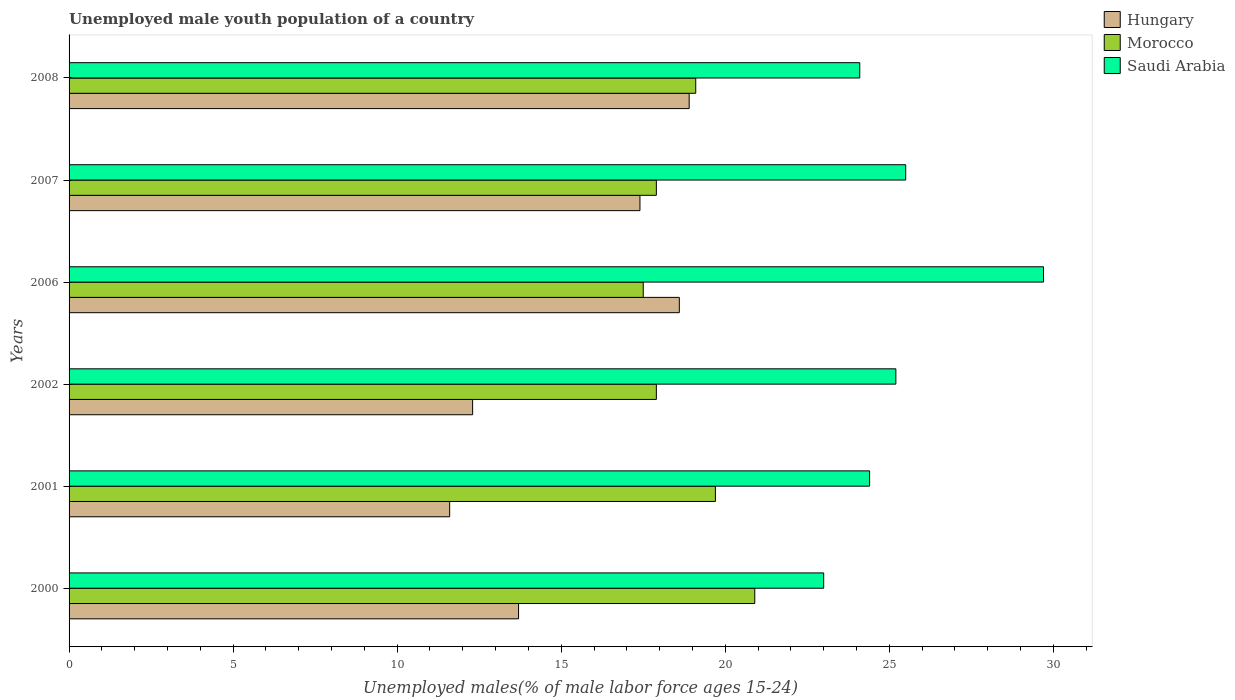How many different coloured bars are there?
Ensure brevity in your answer.  3. How many groups of bars are there?
Make the answer very short. 6. How many bars are there on the 5th tick from the top?
Ensure brevity in your answer.  3. How many bars are there on the 5th tick from the bottom?
Keep it short and to the point. 3. What is the label of the 6th group of bars from the top?
Offer a very short reply. 2000. In how many cases, is the number of bars for a given year not equal to the number of legend labels?
Ensure brevity in your answer.  0. What is the percentage of unemployed male youth population in Hungary in 2000?
Your answer should be compact. 13.7. Across all years, what is the maximum percentage of unemployed male youth population in Morocco?
Offer a very short reply. 20.9. In which year was the percentage of unemployed male youth population in Hungary minimum?
Keep it short and to the point. 2001. What is the total percentage of unemployed male youth population in Hungary in the graph?
Make the answer very short. 92.5. What is the difference between the percentage of unemployed male youth population in Saudi Arabia in 2006 and that in 2007?
Ensure brevity in your answer.  4.2. What is the difference between the percentage of unemployed male youth population in Saudi Arabia in 2006 and the percentage of unemployed male youth population in Morocco in 2007?
Give a very brief answer. 11.8. What is the average percentage of unemployed male youth population in Morocco per year?
Provide a succinct answer. 18.83. In the year 2001, what is the difference between the percentage of unemployed male youth population in Hungary and percentage of unemployed male youth population in Saudi Arabia?
Offer a terse response. -12.8. What is the ratio of the percentage of unemployed male youth population in Saudi Arabia in 2000 to that in 2007?
Give a very brief answer. 0.9. What is the difference between the highest and the second highest percentage of unemployed male youth population in Hungary?
Provide a succinct answer. 0.3. What is the difference between the highest and the lowest percentage of unemployed male youth population in Saudi Arabia?
Your answer should be very brief. 6.7. In how many years, is the percentage of unemployed male youth population in Hungary greater than the average percentage of unemployed male youth population in Hungary taken over all years?
Your answer should be very brief. 3. Is the sum of the percentage of unemployed male youth population in Morocco in 2006 and 2007 greater than the maximum percentage of unemployed male youth population in Saudi Arabia across all years?
Provide a short and direct response. Yes. What does the 1st bar from the top in 2000 represents?
Offer a very short reply. Saudi Arabia. What does the 2nd bar from the bottom in 2002 represents?
Provide a succinct answer. Morocco. Is it the case that in every year, the sum of the percentage of unemployed male youth population in Saudi Arabia and percentage of unemployed male youth population in Hungary is greater than the percentage of unemployed male youth population in Morocco?
Provide a succinct answer. Yes. Are the values on the major ticks of X-axis written in scientific E-notation?
Provide a short and direct response. No. Does the graph contain any zero values?
Offer a very short reply. No. Where does the legend appear in the graph?
Provide a short and direct response. Top right. How are the legend labels stacked?
Keep it short and to the point. Vertical. What is the title of the graph?
Offer a very short reply. Unemployed male youth population of a country. What is the label or title of the X-axis?
Your answer should be very brief. Unemployed males(% of male labor force ages 15-24). What is the Unemployed males(% of male labor force ages 15-24) in Hungary in 2000?
Provide a short and direct response. 13.7. What is the Unemployed males(% of male labor force ages 15-24) of Morocco in 2000?
Offer a very short reply. 20.9. What is the Unemployed males(% of male labor force ages 15-24) of Hungary in 2001?
Provide a succinct answer. 11.6. What is the Unemployed males(% of male labor force ages 15-24) of Morocco in 2001?
Provide a short and direct response. 19.7. What is the Unemployed males(% of male labor force ages 15-24) in Saudi Arabia in 2001?
Make the answer very short. 24.4. What is the Unemployed males(% of male labor force ages 15-24) in Hungary in 2002?
Ensure brevity in your answer.  12.3. What is the Unemployed males(% of male labor force ages 15-24) of Morocco in 2002?
Your answer should be compact. 17.9. What is the Unemployed males(% of male labor force ages 15-24) of Saudi Arabia in 2002?
Your answer should be compact. 25.2. What is the Unemployed males(% of male labor force ages 15-24) of Hungary in 2006?
Your answer should be very brief. 18.6. What is the Unemployed males(% of male labor force ages 15-24) of Morocco in 2006?
Give a very brief answer. 17.5. What is the Unemployed males(% of male labor force ages 15-24) in Saudi Arabia in 2006?
Provide a succinct answer. 29.7. What is the Unemployed males(% of male labor force ages 15-24) of Hungary in 2007?
Offer a terse response. 17.4. What is the Unemployed males(% of male labor force ages 15-24) of Morocco in 2007?
Give a very brief answer. 17.9. What is the Unemployed males(% of male labor force ages 15-24) in Saudi Arabia in 2007?
Your answer should be very brief. 25.5. What is the Unemployed males(% of male labor force ages 15-24) of Hungary in 2008?
Your response must be concise. 18.9. What is the Unemployed males(% of male labor force ages 15-24) of Morocco in 2008?
Make the answer very short. 19.1. What is the Unemployed males(% of male labor force ages 15-24) of Saudi Arabia in 2008?
Keep it short and to the point. 24.1. Across all years, what is the maximum Unemployed males(% of male labor force ages 15-24) of Hungary?
Your response must be concise. 18.9. Across all years, what is the maximum Unemployed males(% of male labor force ages 15-24) in Morocco?
Make the answer very short. 20.9. Across all years, what is the maximum Unemployed males(% of male labor force ages 15-24) of Saudi Arabia?
Your answer should be compact. 29.7. Across all years, what is the minimum Unemployed males(% of male labor force ages 15-24) in Hungary?
Offer a terse response. 11.6. Across all years, what is the minimum Unemployed males(% of male labor force ages 15-24) in Morocco?
Offer a very short reply. 17.5. What is the total Unemployed males(% of male labor force ages 15-24) of Hungary in the graph?
Give a very brief answer. 92.5. What is the total Unemployed males(% of male labor force ages 15-24) in Morocco in the graph?
Offer a very short reply. 113. What is the total Unemployed males(% of male labor force ages 15-24) in Saudi Arabia in the graph?
Make the answer very short. 151.9. What is the difference between the Unemployed males(% of male labor force ages 15-24) in Morocco in 2000 and that in 2001?
Ensure brevity in your answer.  1.2. What is the difference between the Unemployed males(% of male labor force ages 15-24) of Saudi Arabia in 2000 and that in 2001?
Make the answer very short. -1.4. What is the difference between the Unemployed males(% of male labor force ages 15-24) of Saudi Arabia in 2000 and that in 2002?
Your answer should be compact. -2.2. What is the difference between the Unemployed males(% of male labor force ages 15-24) in Hungary in 2000 and that in 2006?
Offer a very short reply. -4.9. What is the difference between the Unemployed males(% of male labor force ages 15-24) of Morocco in 2000 and that in 2006?
Give a very brief answer. 3.4. What is the difference between the Unemployed males(% of male labor force ages 15-24) in Hungary in 2000 and that in 2007?
Your answer should be very brief. -3.7. What is the difference between the Unemployed males(% of male labor force ages 15-24) of Saudi Arabia in 2000 and that in 2007?
Provide a succinct answer. -2.5. What is the difference between the Unemployed males(% of male labor force ages 15-24) of Hungary in 2000 and that in 2008?
Offer a terse response. -5.2. What is the difference between the Unemployed males(% of male labor force ages 15-24) of Morocco in 2000 and that in 2008?
Make the answer very short. 1.8. What is the difference between the Unemployed males(% of male labor force ages 15-24) of Saudi Arabia in 2000 and that in 2008?
Offer a very short reply. -1.1. What is the difference between the Unemployed males(% of male labor force ages 15-24) in Hungary in 2001 and that in 2002?
Your answer should be very brief. -0.7. What is the difference between the Unemployed males(% of male labor force ages 15-24) in Morocco in 2001 and that in 2002?
Your answer should be very brief. 1.8. What is the difference between the Unemployed males(% of male labor force ages 15-24) in Hungary in 2001 and that in 2006?
Provide a short and direct response. -7. What is the difference between the Unemployed males(% of male labor force ages 15-24) of Morocco in 2001 and that in 2006?
Give a very brief answer. 2.2. What is the difference between the Unemployed males(% of male labor force ages 15-24) in Morocco in 2001 and that in 2008?
Your response must be concise. 0.6. What is the difference between the Unemployed males(% of male labor force ages 15-24) of Saudi Arabia in 2001 and that in 2008?
Keep it short and to the point. 0.3. What is the difference between the Unemployed males(% of male labor force ages 15-24) in Hungary in 2002 and that in 2007?
Your response must be concise. -5.1. What is the difference between the Unemployed males(% of male labor force ages 15-24) in Saudi Arabia in 2002 and that in 2007?
Offer a very short reply. -0.3. What is the difference between the Unemployed males(% of male labor force ages 15-24) of Hungary in 2006 and that in 2007?
Your answer should be compact. 1.2. What is the difference between the Unemployed males(% of male labor force ages 15-24) in Hungary in 2006 and that in 2008?
Your response must be concise. -0.3. What is the difference between the Unemployed males(% of male labor force ages 15-24) of Morocco in 2006 and that in 2008?
Your answer should be compact. -1.6. What is the difference between the Unemployed males(% of male labor force ages 15-24) in Saudi Arabia in 2006 and that in 2008?
Offer a very short reply. 5.6. What is the difference between the Unemployed males(% of male labor force ages 15-24) in Saudi Arabia in 2007 and that in 2008?
Your answer should be compact. 1.4. What is the difference between the Unemployed males(% of male labor force ages 15-24) of Hungary in 2000 and the Unemployed males(% of male labor force ages 15-24) of Morocco in 2001?
Your response must be concise. -6. What is the difference between the Unemployed males(% of male labor force ages 15-24) of Hungary in 2000 and the Unemployed males(% of male labor force ages 15-24) of Saudi Arabia in 2001?
Provide a short and direct response. -10.7. What is the difference between the Unemployed males(% of male labor force ages 15-24) in Morocco in 2000 and the Unemployed males(% of male labor force ages 15-24) in Saudi Arabia in 2001?
Ensure brevity in your answer.  -3.5. What is the difference between the Unemployed males(% of male labor force ages 15-24) of Hungary in 2000 and the Unemployed males(% of male labor force ages 15-24) of Saudi Arabia in 2002?
Provide a short and direct response. -11.5. What is the difference between the Unemployed males(% of male labor force ages 15-24) in Morocco in 2000 and the Unemployed males(% of male labor force ages 15-24) in Saudi Arabia in 2002?
Offer a very short reply. -4.3. What is the difference between the Unemployed males(% of male labor force ages 15-24) in Hungary in 2000 and the Unemployed males(% of male labor force ages 15-24) in Morocco in 2007?
Your answer should be very brief. -4.2. What is the difference between the Unemployed males(% of male labor force ages 15-24) in Hungary in 2000 and the Unemployed males(% of male labor force ages 15-24) in Saudi Arabia in 2008?
Provide a short and direct response. -10.4. What is the difference between the Unemployed males(% of male labor force ages 15-24) of Hungary in 2001 and the Unemployed males(% of male labor force ages 15-24) of Morocco in 2002?
Offer a very short reply. -6.3. What is the difference between the Unemployed males(% of male labor force ages 15-24) in Morocco in 2001 and the Unemployed males(% of male labor force ages 15-24) in Saudi Arabia in 2002?
Offer a very short reply. -5.5. What is the difference between the Unemployed males(% of male labor force ages 15-24) in Hungary in 2001 and the Unemployed males(% of male labor force ages 15-24) in Saudi Arabia in 2006?
Provide a short and direct response. -18.1. What is the difference between the Unemployed males(% of male labor force ages 15-24) in Hungary in 2001 and the Unemployed males(% of male labor force ages 15-24) in Morocco in 2007?
Ensure brevity in your answer.  -6.3. What is the difference between the Unemployed males(% of male labor force ages 15-24) in Hungary in 2001 and the Unemployed males(% of male labor force ages 15-24) in Saudi Arabia in 2007?
Provide a succinct answer. -13.9. What is the difference between the Unemployed males(% of male labor force ages 15-24) in Morocco in 2001 and the Unemployed males(% of male labor force ages 15-24) in Saudi Arabia in 2007?
Make the answer very short. -5.8. What is the difference between the Unemployed males(% of male labor force ages 15-24) of Hungary in 2001 and the Unemployed males(% of male labor force ages 15-24) of Morocco in 2008?
Ensure brevity in your answer.  -7.5. What is the difference between the Unemployed males(% of male labor force ages 15-24) of Hungary in 2001 and the Unemployed males(% of male labor force ages 15-24) of Saudi Arabia in 2008?
Your answer should be very brief. -12.5. What is the difference between the Unemployed males(% of male labor force ages 15-24) in Hungary in 2002 and the Unemployed males(% of male labor force ages 15-24) in Morocco in 2006?
Your answer should be very brief. -5.2. What is the difference between the Unemployed males(% of male labor force ages 15-24) of Hungary in 2002 and the Unemployed males(% of male labor force ages 15-24) of Saudi Arabia in 2006?
Your response must be concise. -17.4. What is the difference between the Unemployed males(% of male labor force ages 15-24) in Morocco in 2002 and the Unemployed males(% of male labor force ages 15-24) in Saudi Arabia in 2006?
Offer a terse response. -11.8. What is the difference between the Unemployed males(% of male labor force ages 15-24) in Morocco in 2002 and the Unemployed males(% of male labor force ages 15-24) in Saudi Arabia in 2008?
Give a very brief answer. -6.2. What is the difference between the Unemployed males(% of male labor force ages 15-24) in Hungary in 2006 and the Unemployed males(% of male labor force ages 15-24) in Morocco in 2007?
Offer a terse response. 0.7. What is the difference between the Unemployed males(% of male labor force ages 15-24) of Morocco in 2006 and the Unemployed males(% of male labor force ages 15-24) of Saudi Arabia in 2007?
Your answer should be compact. -8. What is the difference between the Unemployed males(% of male labor force ages 15-24) of Morocco in 2007 and the Unemployed males(% of male labor force ages 15-24) of Saudi Arabia in 2008?
Provide a short and direct response. -6.2. What is the average Unemployed males(% of male labor force ages 15-24) of Hungary per year?
Ensure brevity in your answer.  15.42. What is the average Unemployed males(% of male labor force ages 15-24) in Morocco per year?
Keep it short and to the point. 18.83. What is the average Unemployed males(% of male labor force ages 15-24) of Saudi Arabia per year?
Give a very brief answer. 25.32. In the year 2000, what is the difference between the Unemployed males(% of male labor force ages 15-24) of Hungary and Unemployed males(% of male labor force ages 15-24) of Morocco?
Offer a terse response. -7.2. In the year 2000, what is the difference between the Unemployed males(% of male labor force ages 15-24) of Hungary and Unemployed males(% of male labor force ages 15-24) of Saudi Arabia?
Keep it short and to the point. -9.3. In the year 2001, what is the difference between the Unemployed males(% of male labor force ages 15-24) in Hungary and Unemployed males(% of male labor force ages 15-24) in Morocco?
Provide a succinct answer. -8.1. In the year 2001, what is the difference between the Unemployed males(% of male labor force ages 15-24) of Morocco and Unemployed males(% of male labor force ages 15-24) of Saudi Arabia?
Ensure brevity in your answer.  -4.7. In the year 2002, what is the difference between the Unemployed males(% of male labor force ages 15-24) of Hungary and Unemployed males(% of male labor force ages 15-24) of Morocco?
Offer a very short reply. -5.6. In the year 2008, what is the difference between the Unemployed males(% of male labor force ages 15-24) in Hungary and Unemployed males(% of male labor force ages 15-24) in Morocco?
Your answer should be compact. -0.2. In the year 2008, what is the difference between the Unemployed males(% of male labor force ages 15-24) in Hungary and Unemployed males(% of male labor force ages 15-24) in Saudi Arabia?
Your response must be concise. -5.2. In the year 2008, what is the difference between the Unemployed males(% of male labor force ages 15-24) of Morocco and Unemployed males(% of male labor force ages 15-24) of Saudi Arabia?
Provide a short and direct response. -5. What is the ratio of the Unemployed males(% of male labor force ages 15-24) in Hungary in 2000 to that in 2001?
Your answer should be very brief. 1.18. What is the ratio of the Unemployed males(% of male labor force ages 15-24) in Morocco in 2000 to that in 2001?
Offer a terse response. 1.06. What is the ratio of the Unemployed males(% of male labor force ages 15-24) of Saudi Arabia in 2000 to that in 2001?
Make the answer very short. 0.94. What is the ratio of the Unemployed males(% of male labor force ages 15-24) in Hungary in 2000 to that in 2002?
Make the answer very short. 1.11. What is the ratio of the Unemployed males(% of male labor force ages 15-24) of Morocco in 2000 to that in 2002?
Ensure brevity in your answer.  1.17. What is the ratio of the Unemployed males(% of male labor force ages 15-24) in Saudi Arabia in 2000 to that in 2002?
Make the answer very short. 0.91. What is the ratio of the Unemployed males(% of male labor force ages 15-24) of Hungary in 2000 to that in 2006?
Keep it short and to the point. 0.74. What is the ratio of the Unemployed males(% of male labor force ages 15-24) in Morocco in 2000 to that in 2006?
Provide a short and direct response. 1.19. What is the ratio of the Unemployed males(% of male labor force ages 15-24) of Saudi Arabia in 2000 to that in 2006?
Provide a short and direct response. 0.77. What is the ratio of the Unemployed males(% of male labor force ages 15-24) in Hungary in 2000 to that in 2007?
Offer a terse response. 0.79. What is the ratio of the Unemployed males(% of male labor force ages 15-24) in Morocco in 2000 to that in 2007?
Your response must be concise. 1.17. What is the ratio of the Unemployed males(% of male labor force ages 15-24) of Saudi Arabia in 2000 to that in 2007?
Make the answer very short. 0.9. What is the ratio of the Unemployed males(% of male labor force ages 15-24) in Hungary in 2000 to that in 2008?
Provide a short and direct response. 0.72. What is the ratio of the Unemployed males(% of male labor force ages 15-24) of Morocco in 2000 to that in 2008?
Provide a succinct answer. 1.09. What is the ratio of the Unemployed males(% of male labor force ages 15-24) in Saudi Arabia in 2000 to that in 2008?
Your response must be concise. 0.95. What is the ratio of the Unemployed males(% of male labor force ages 15-24) in Hungary in 2001 to that in 2002?
Provide a short and direct response. 0.94. What is the ratio of the Unemployed males(% of male labor force ages 15-24) of Morocco in 2001 to that in 2002?
Your response must be concise. 1.1. What is the ratio of the Unemployed males(% of male labor force ages 15-24) in Saudi Arabia in 2001 to that in 2002?
Your answer should be compact. 0.97. What is the ratio of the Unemployed males(% of male labor force ages 15-24) of Hungary in 2001 to that in 2006?
Keep it short and to the point. 0.62. What is the ratio of the Unemployed males(% of male labor force ages 15-24) of Morocco in 2001 to that in 2006?
Your response must be concise. 1.13. What is the ratio of the Unemployed males(% of male labor force ages 15-24) in Saudi Arabia in 2001 to that in 2006?
Offer a terse response. 0.82. What is the ratio of the Unemployed males(% of male labor force ages 15-24) in Morocco in 2001 to that in 2007?
Offer a terse response. 1.1. What is the ratio of the Unemployed males(% of male labor force ages 15-24) in Saudi Arabia in 2001 to that in 2007?
Give a very brief answer. 0.96. What is the ratio of the Unemployed males(% of male labor force ages 15-24) in Hungary in 2001 to that in 2008?
Provide a short and direct response. 0.61. What is the ratio of the Unemployed males(% of male labor force ages 15-24) of Morocco in 2001 to that in 2008?
Your answer should be compact. 1.03. What is the ratio of the Unemployed males(% of male labor force ages 15-24) of Saudi Arabia in 2001 to that in 2008?
Provide a succinct answer. 1.01. What is the ratio of the Unemployed males(% of male labor force ages 15-24) of Hungary in 2002 to that in 2006?
Provide a succinct answer. 0.66. What is the ratio of the Unemployed males(% of male labor force ages 15-24) of Morocco in 2002 to that in 2006?
Keep it short and to the point. 1.02. What is the ratio of the Unemployed males(% of male labor force ages 15-24) of Saudi Arabia in 2002 to that in 2006?
Provide a short and direct response. 0.85. What is the ratio of the Unemployed males(% of male labor force ages 15-24) of Hungary in 2002 to that in 2007?
Provide a short and direct response. 0.71. What is the ratio of the Unemployed males(% of male labor force ages 15-24) of Morocco in 2002 to that in 2007?
Your answer should be compact. 1. What is the ratio of the Unemployed males(% of male labor force ages 15-24) in Hungary in 2002 to that in 2008?
Make the answer very short. 0.65. What is the ratio of the Unemployed males(% of male labor force ages 15-24) of Morocco in 2002 to that in 2008?
Keep it short and to the point. 0.94. What is the ratio of the Unemployed males(% of male labor force ages 15-24) in Saudi Arabia in 2002 to that in 2008?
Provide a succinct answer. 1.05. What is the ratio of the Unemployed males(% of male labor force ages 15-24) in Hungary in 2006 to that in 2007?
Provide a succinct answer. 1.07. What is the ratio of the Unemployed males(% of male labor force ages 15-24) of Morocco in 2006 to that in 2007?
Offer a terse response. 0.98. What is the ratio of the Unemployed males(% of male labor force ages 15-24) of Saudi Arabia in 2006 to that in 2007?
Give a very brief answer. 1.16. What is the ratio of the Unemployed males(% of male labor force ages 15-24) of Hungary in 2006 to that in 2008?
Your answer should be compact. 0.98. What is the ratio of the Unemployed males(% of male labor force ages 15-24) of Morocco in 2006 to that in 2008?
Offer a very short reply. 0.92. What is the ratio of the Unemployed males(% of male labor force ages 15-24) in Saudi Arabia in 2006 to that in 2008?
Your answer should be very brief. 1.23. What is the ratio of the Unemployed males(% of male labor force ages 15-24) of Hungary in 2007 to that in 2008?
Your answer should be very brief. 0.92. What is the ratio of the Unemployed males(% of male labor force ages 15-24) of Morocco in 2007 to that in 2008?
Make the answer very short. 0.94. What is the ratio of the Unemployed males(% of male labor force ages 15-24) in Saudi Arabia in 2007 to that in 2008?
Ensure brevity in your answer.  1.06. What is the difference between the highest and the second highest Unemployed males(% of male labor force ages 15-24) of Hungary?
Your response must be concise. 0.3. What is the difference between the highest and the second highest Unemployed males(% of male labor force ages 15-24) in Morocco?
Make the answer very short. 1.2. What is the difference between the highest and the second highest Unemployed males(% of male labor force ages 15-24) in Saudi Arabia?
Your answer should be compact. 4.2. What is the difference between the highest and the lowest Unemployed males(% of male labor force ages 15-24) in Hungary?
Give a very brief answer. 7.3. What is the difference between the highest and the lowest Unemployed males(% of male labor force ages 15-24) in Saudi Arabia?
Keep it short and to the point. 6.7. 